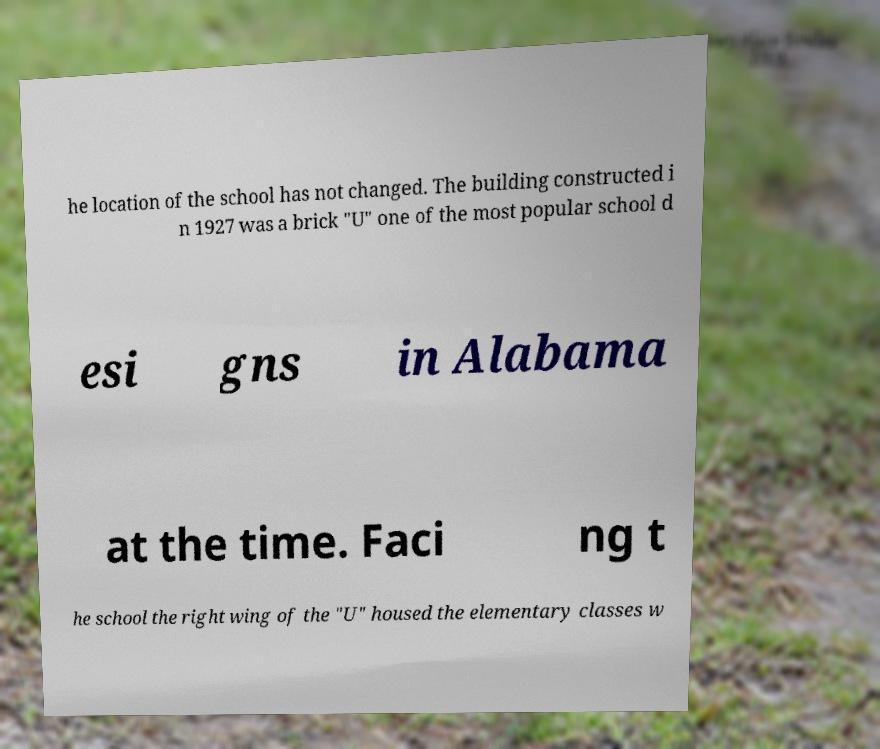Could you assist in decoding the text presented in this image and type it out clearly? he location of the school has not changed. The building constructed i n 1927 was a brick "U" one of the most popular school d esi gns in Alabama at the time. Faci ng t he school the right wing of the "U" housed the elementary classes w 